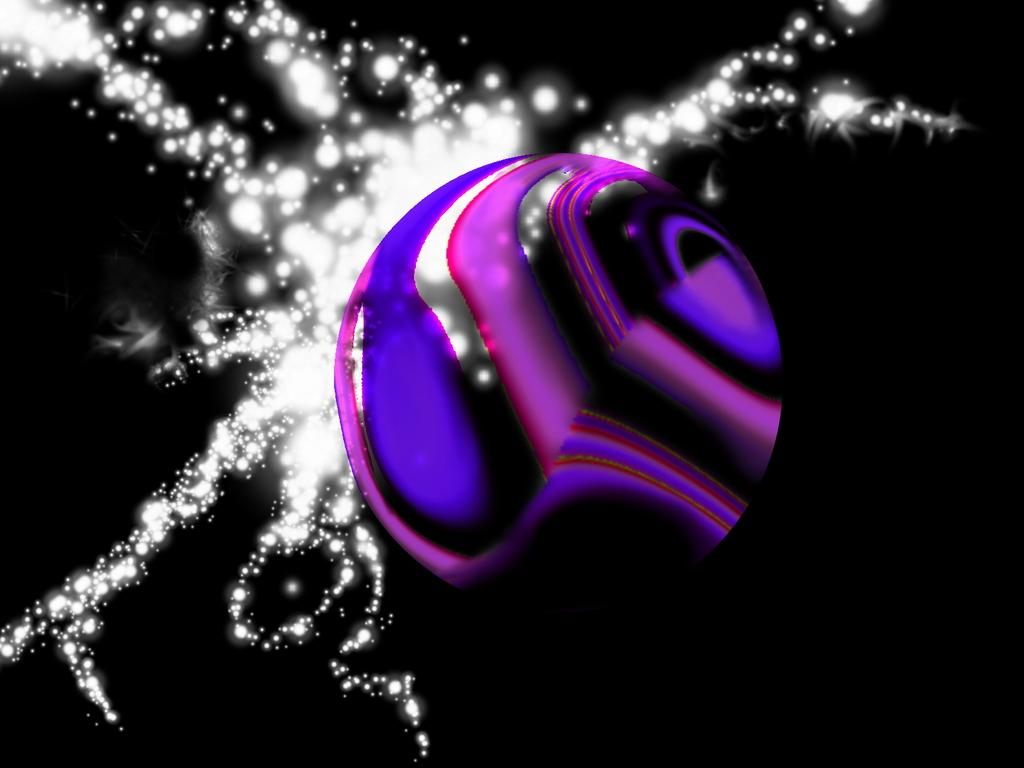What shape is the main object in the image? There is a sphere in the image. What colors are present on the sphere? The sphere has pink and purple colors. What additional detail can be seen in the image? There is a white color sparkle in the image. How would you describe the overall appearance of the image? The background of the image is dark. Can you tell me how many books are on the shelf in the image? There is no shelf or books present in the image; it features a sphere with pink and purple colors, a white color sparkle, and a dark background. 